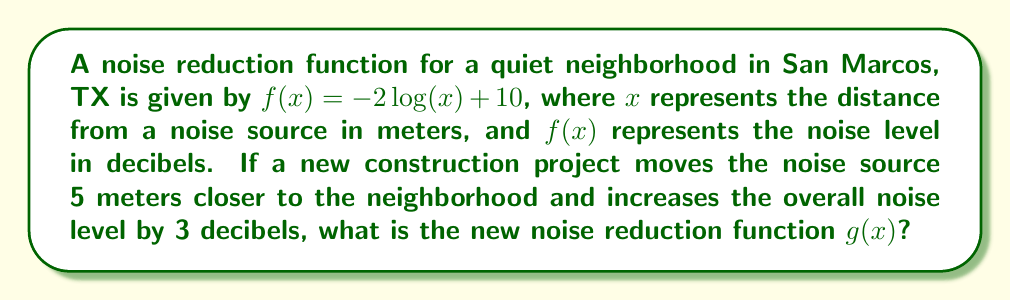Can you answer this question? To solve this problem, we need to apply both horizontal and vertical shifts to the original function $f(x)$:

1. Horizontal shift:
   The noise source is moved 5 meters closer, so we need to shift the function 5 units to the left.
   This is achieved by replacing $x$ with $(x+5)$ in the original function.

2. Vertical shift:
   The overall noise level is increased by 3 decibels, so we need to shift the function 3 units up.
   This is done by adding 3 to the entire function.

Applying these transformations to $f(x) = -2\log(x) + 10$:

Step 1: Horizontal shift
$$f(x+5) = -2\log(x+5) + 10$$

Step 2: Vertical shift
$$g(x) = f(x+5) + 3 = -2\log(x+5) + 10 + 3$$

Step 3: Simplify
$$g(x) = -2\log(x+5) + 13$$

Therefore, the new noise reduction function $g(x)$ is $-2\log(x+5) + 13$.
Answer: $g(x) = -2\log(x+5) + 13$ 